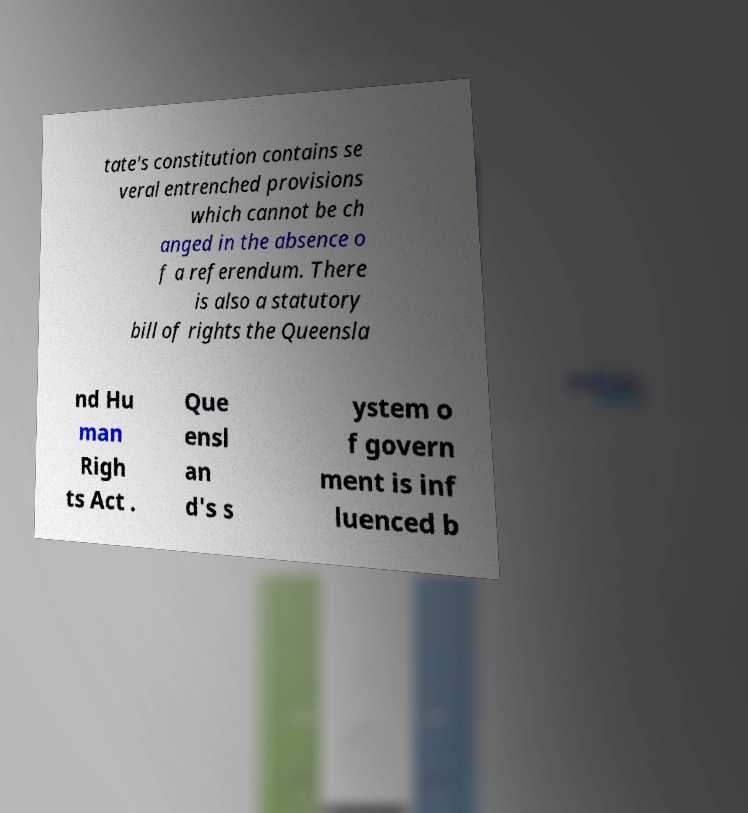I need the written content from this picture converted into text. Can you do that? tate's constitution contains se veral entrenched provisions which cannot be ch anged in the absence o f a referendum. There is also a statutory bill of rights the Queensla nd Hu man Righ ts Act . Que ensl an d's s ystem o f govern ment is inf luenced b 